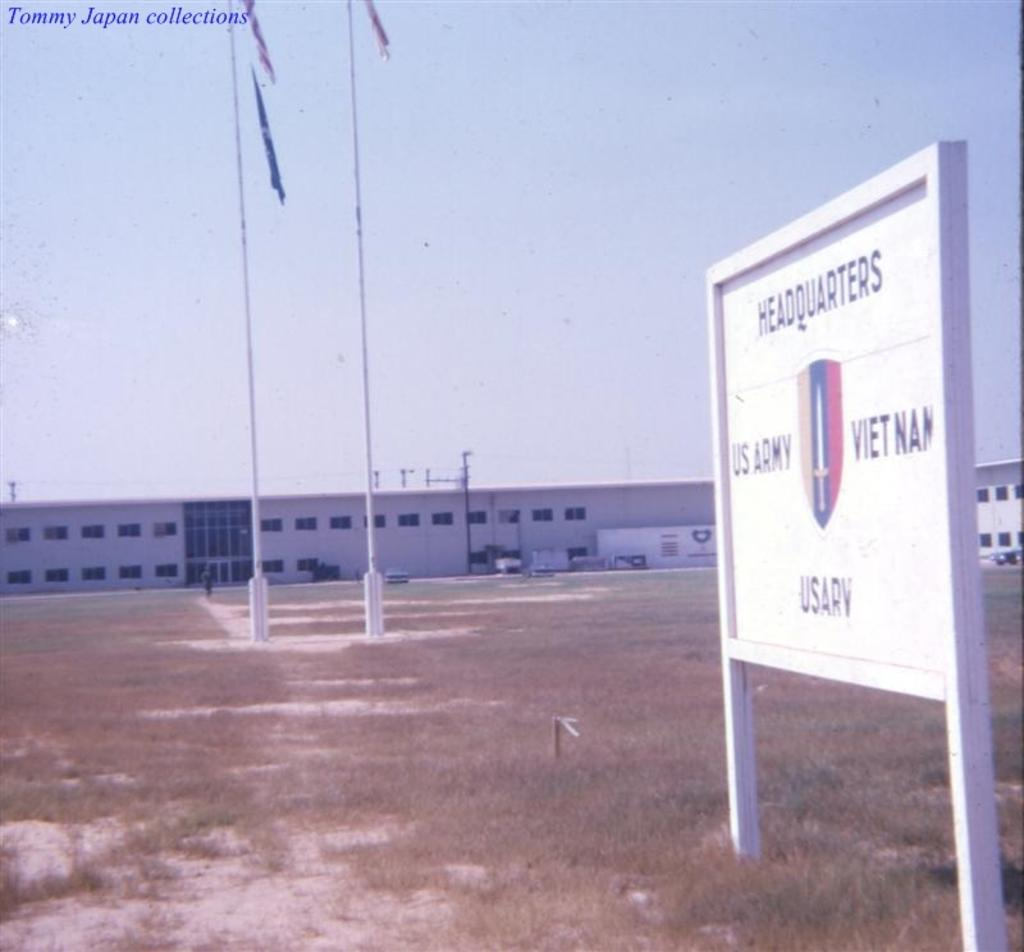<image>
Offer a succinct explanation of the picture presented. The exterior of a US Army headquarters building. 